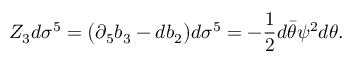Convert formula to latex. <formula><loc_0><loc_0><loc_500><loc_500>Z _ { 3 } d \sigma ^ { 5 } = \left ( \partial _ { 5 } b _ { 3 } - d b _ { 2 } \right ) d \sigma ^ { 5 } = - { \frac { 1 } { 2 } } d \bar { \theta } \psi ^ { 2 } d \theta .</formula> 